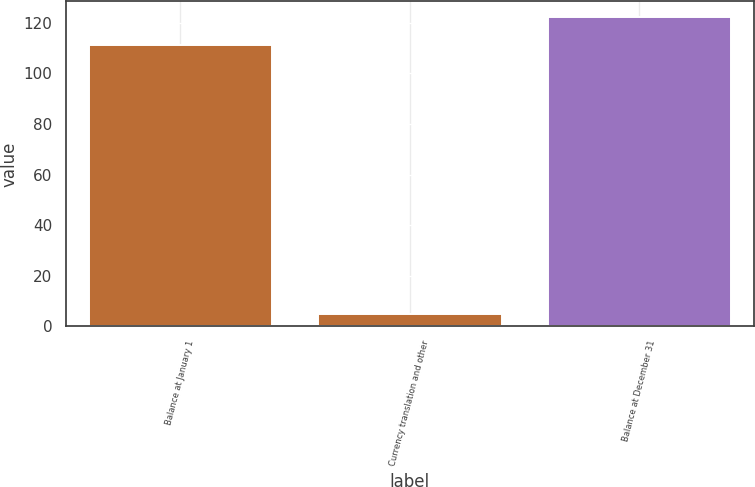Convert chart to OTSL. <chart><loc_0><loc_0><loc_500><loc_500><bar_chart><fcel>Balance at January 1<fcel>Currency translation and other<fcel>Balance at December 31<nl><fcel>111.2<fcel>5.1<fcel>122.41<nl></chart> 